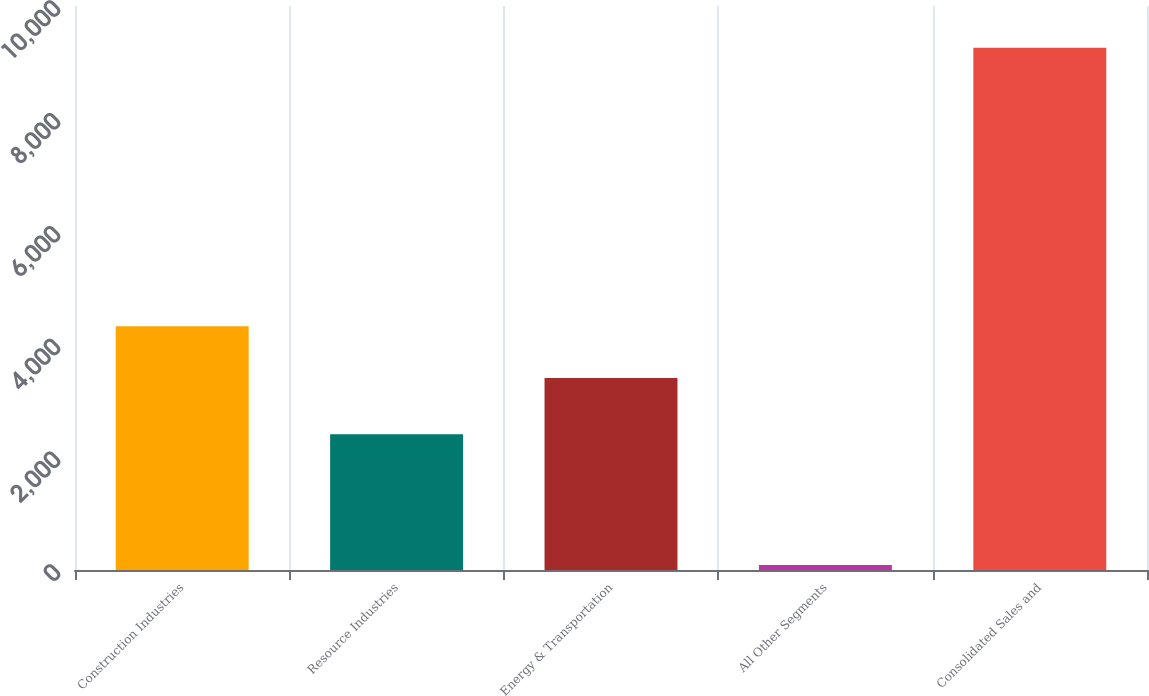Convert chart to OTSL. <chart><loc_0><loc_0><loc_500><loc_500><bar_chart><fcel>Construction Industries<fcel>Resource Industries<fcel>Energy & Transportation<fcel>All Other Segments<fcel>Consolidated Sales and<nl><fcel>4320.2<fcel>2409<fcel>3403<fcel>88<fcel>9260<nl></chart> 